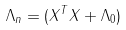Convert formula to latex. <formula><loc_0><loc_0><loc_500><loc_500>\Lambda _ { n } = ( X ^ { T } X + \Lambda _ { 0 } )</formula> 